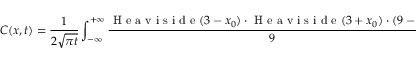Convert formula to latex. <formula><loc_0><loc_0><loc_500><loc_500>C ( x , t ) = \frac { 1 } { 2 \sqrt { \pi t } } \int _ { - \infty } ^ { + \infty } \frac { H e a v i s i d e ( 3 - x _ { 0 } ) \cdot H e a v i s i d e ( 3 + x _ { 0 } ) \cdot ( 9 - x _ { 0 } ^ { 2 } ) } { 9 } \cdot e ^ { \frac { ( x - x _ { 0 } ) ^ { 2 } } { 4 D t } } d x _ { 0 } .</formula> 